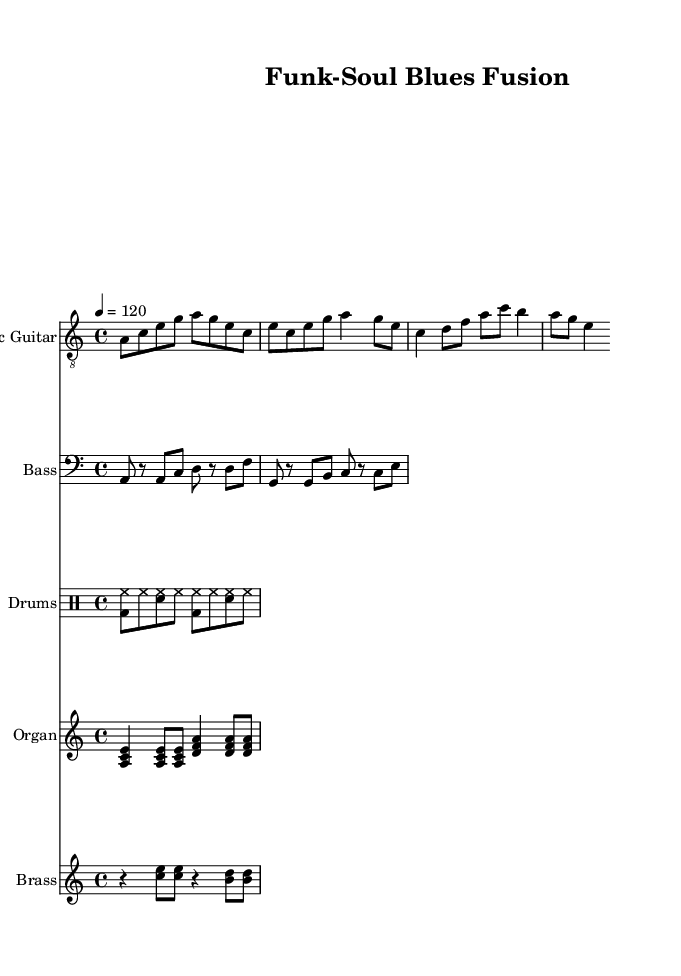What is the key signature of this music? The key signature is A minor, which contains no sharps or flats. This is identified by the lack of accidentals in the music and the presence of A as the tonic note throughout.
Answer: A minor What is the time signature of this music? The time signature is 4/4, which is indicated at the beginning of the score. This means there are four beats in each measure and the quarter note receives one beat.
Answer: 4/4 What is the tempo marking for this piece? The tempo marking is 120, which is specified with the indication '4 = 120' at the beginning. This means there are 120 beats per minute.
Answer: 120 How many measures are in the electric guitar part? The electric guitar part has a total of 8 measures, which can be counted by identifying the bar lines in the staff. Each measure is defined by a set of bar lines separating the notes.
Answer: 8 Which instruments feature a syncopated rhythm? The brass section features a syncopated rhythm, as indicated by the offbeat placement of the notes. The sense of delay creates a rhythmic tension that is characteristic of funk and soul influences.
Answer: Brass What elements contribute to the fusion style of this piece? The fusion style is achieved through the incorporation of funk elements, such as the rhythmic bass lines, and soul elements visible in the brass hits, combined with the traditional blues structure. This blend enhances the overall flavor of electric blues.
Answer: Funk and soul What is the source of the drum pattern used in this score? The drum pattern originates from a typical shuffle rhythm, which is common in blues music, but here it incorporates elements of funk with hi-hat accents. This creates a lively groove suitable for the blues fusion genre.
Answer: Shuffle rhythm 